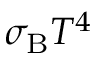<formula> <loc_0><loc_0><loc_500><loc_500>\sigma _ { B } T ^ { 4 }</formula> 